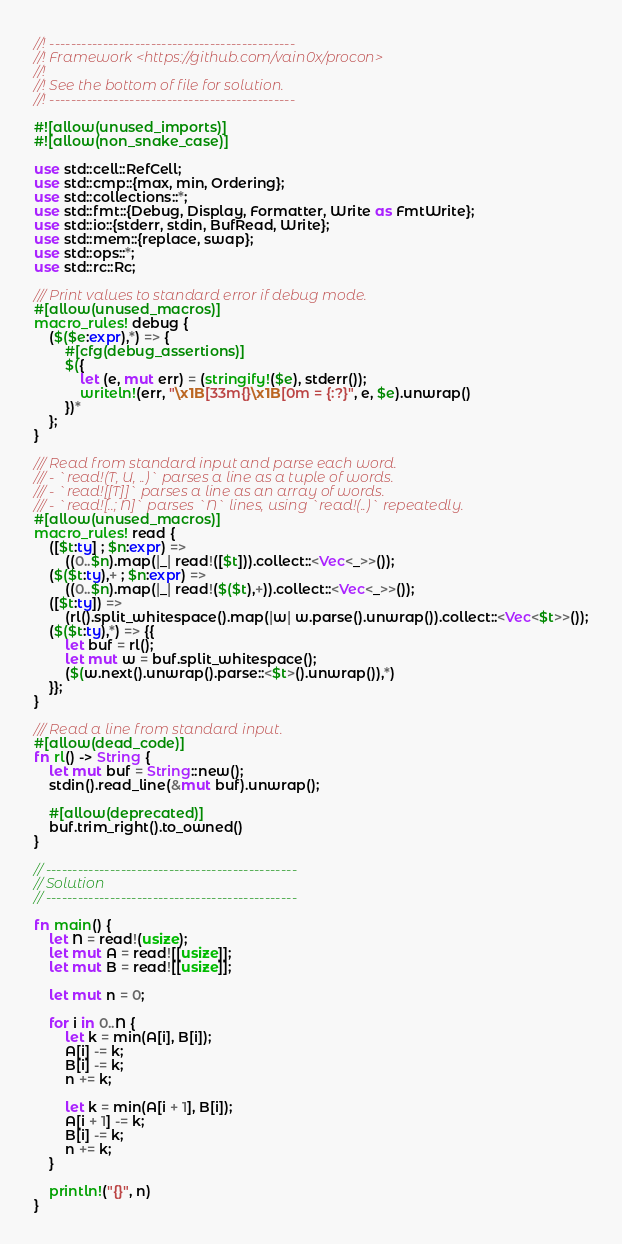Convert code to text. <code><loc_0><loc_0><loc_500><loc_500><_Rust_>//! ----------------------------------------------
//! Framework <https://github.com/vain0x/procon>
//!
//! See the bottom of file for solution.
//! ----------------------------------------------

#![allow(unused_imports)]
#![allow(non_snake_case)]

use std::cell::RefCell;
use std::cmp::{max, min, Ordering};
use std::collections::*;
use std::fmt::{Debug, Display, Formatter, Write as FmtWrite};
use std::io::{stderr, stdin, BufRead, Write};
use std::mem::{replace, swap};
use std::ops::*;
use std::rc::Rc;

/// Print values to standard error if debug mode.
#[allow(unused_macros)]
macro_rules! debug {
    ($($e:expr),*) => {
        #[cfg(debug_assertions)]
        $({
            let (e, mut err) = (stringify!($e), stderr());
            writeln!(err, "\x1B[33m{}\x1B[0m = {:?}", e, $e).unwrap()
        })*
    };
}

/// Read from standard input and parse each word.
/// - `read!(T, U, ..)` parses a line as a tuple of words.
/// - `read![[T]]` parses a line as an array of words.
/// - `read![..; N]` parses `N` lines, using `read!(..)` repeatedly.
#[allow(unused_macros)]
macro_rules! read {
    ([$t:ty] ; $n:expr) =>
        ((0..$n).map(|_| read!([$t])).collect::<Vec<_>>());
    ($($t:ty),+ ; $n:expr) =>
        ((0..$n).map(|_| read!($($t),+)).collect::<Vec<_>>());
    ([$t:ty]) =>
        (rl().split_whitespace().map(|w| w.parse().unwrap()).collect::<Vec<$t>>());
    ($($t:ty),*) => {{
        let buf = rl();
        let mut w = buf.split_whitespace();
        ($(w.next().unwrap().parse::<$t>().unwrap()),*)
    }};
}

/// Read a line from standard input.
#[allow(dead_code)]
fn rl() -> String {
    let mut buf = String::new();
    stdin().read_line(&mut buf).unwrap();

    #[allow(deprecated)]
    buf.trim_right().to_owned()
}

// -----------------------------------------------
// Solution
// -----------------------------------------------

fn main() {
    let N = read!(usize);
    let mut A = read![[usize]];
    let mut B = read![[usize]];

    let mut n = 0;

    for i in 0..N {
        let k = min(A[i], B[i]);
        A[i] -= k;
        B[i] -= k;
        n += k;

        let k = min(A[i + 1], B[i]);
        A[i + 1] -= k;
        B[i] -= k;
        n += k;
    }

    println!("{}", n)
}
</code> 